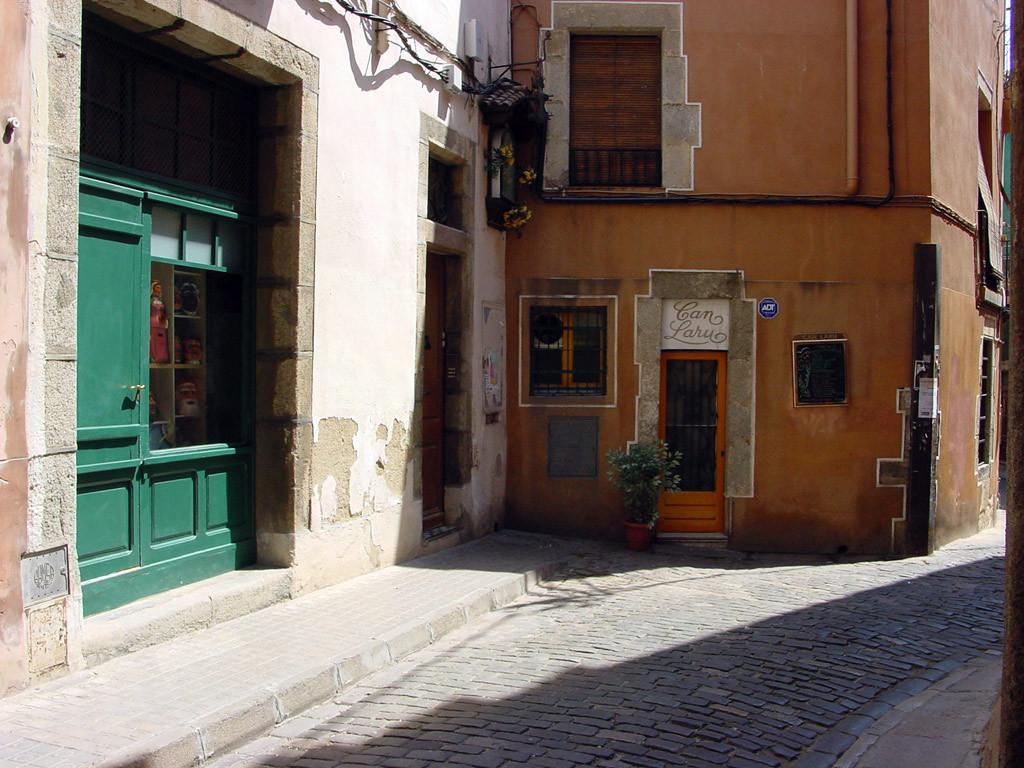Please provide a concise description of this image. In this image we can see a group of buildings with windows, doors, sign board with some text, plants and some dolls placed in the racks and the pathway. 